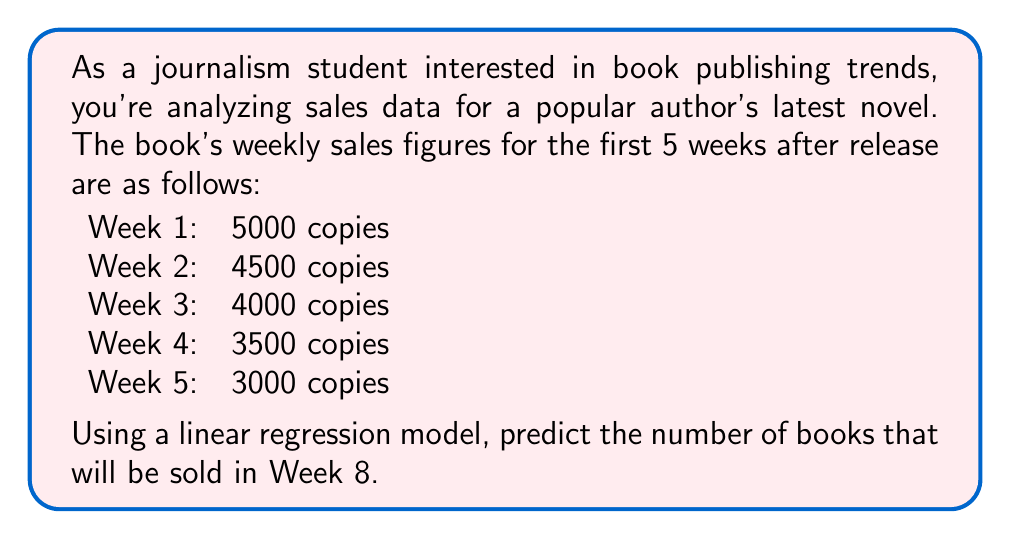Provide a solution to this math problem. To solve this problem, we'll use linear regression to model the relationship between time (weeks) and sales. Then we'll use the model to predict sales for Week 8.

Step 1: Set up the data
Let $x$ represent the week number and $y$ represent the sales.
$(x_1, y_1) = (1, 5000)$
$(x_2, y_2) = (2, 4500)$
$(x_3, y_3) = (3, 4000)$
$(x_4, y_4) = (4, 3500)$
$(x_5, y_5) = (5, 3000)$

Step 2: Calculate the means
$\bar{x} = \frac{1 + 2 + 3 + 4 + 5}{5} = 3$
$\bar{y} = \frac{5000 + 4500 + 4000 + 3500 + 3000}{5} = 4000$

Step 3: Calculate the slope (m) of the regression line
$$m = \frac{\sum_{i=1}^{n} (x_i - \bar{x})(y_i - \bar{y})}{\sum_{i=1}^{n} (x_i - \bar{x})^2}$$

$\sum_{i=1}^{n} (x_i - \bar{x})(y_i - \bar{y}) = (-2)(1000) + (-1)(500) + (0)(0) + (1)(-500) + (2)(-1000) = -3500$

$\sum_{i=1}^{n} (x_i - \bar{x})^2 = (-2)^2 + (-1)^2 + (0)^2 + (1)^2 + (2)^2 = 10$

$m = \frac{-3500}{10} = -350$

Step 4: Calculate the y-intercept (b)
$b = \bar{y} - m\bar{x} = 4000 - (-350)(3) = 5050$

Step 5: Form the linear regression equation
$y = mx + b$
$y = -350x + 5050$

Step 6: Predict sales for Week 8
$y = -350(8) + 5050 = 2250$

Therefore, the predicted sales for Week 8 is 2250 copies.
Answer: 2250 copies 